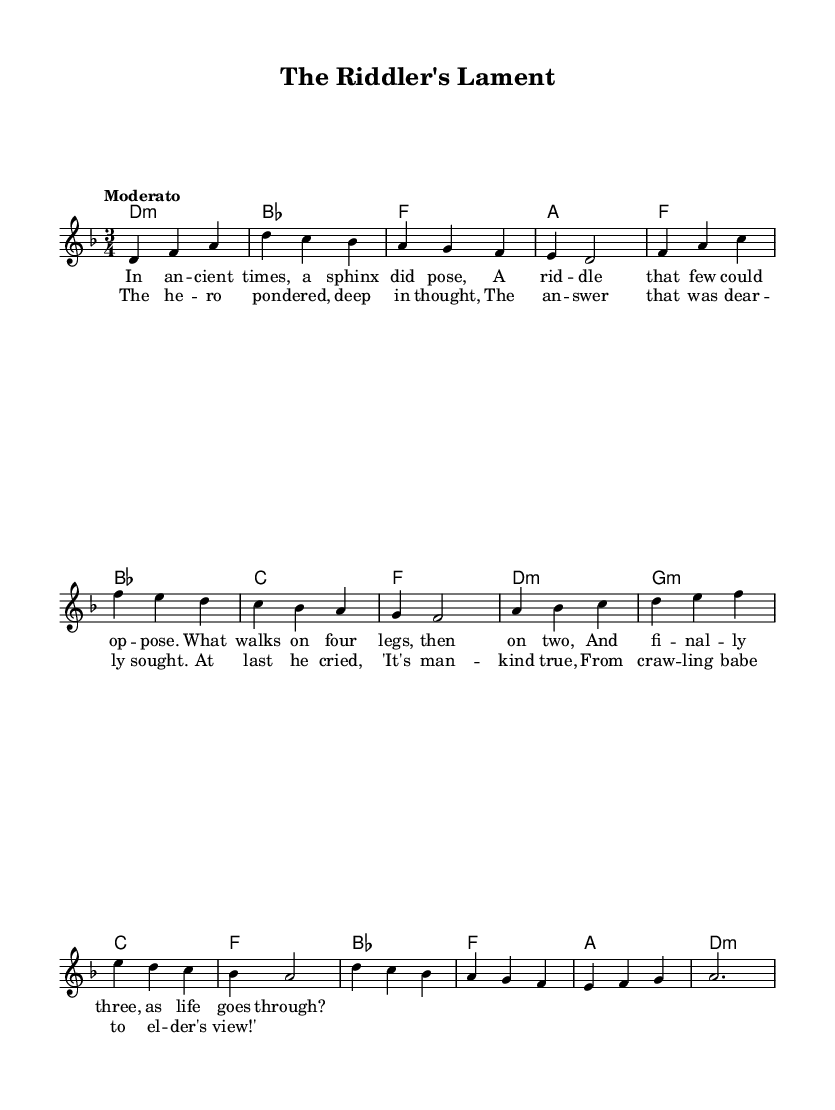What is the key signature of this music? The key signature is specified by the initial notes in the key signature area, which shows a one flat (B flat). The music is in D minor, which has one flat.
Answer: D minor What is the time signature of this music? The time signature is indicated in the beginning section of the sheet music, displaying a "3/4" time frame. This means there are three beats in each measure and the quarter note gets one beat.
Answer: 3/4 What is the tempo marking for this piece? The tempo marking appears near the beginning of the score, listed as "Moderato." This indicates a moderate speed for the piece.
Answer: Moderato How many verses are present in the lyrics? By examining the lyrical sections in the sheet music, there are two distinct parts, each labeled as a verse.
Answer: 2 What is the solution to the riddle presented in the lyrics? The solution to the riddle can be derived by closely reading the lyrics where it states, "It's mankind true," indicating the answer derived from the riddle posed in the first verse.
Answer: Mankind What is the first note of the melody? The first note of the melody is indicated at the beginning of the melody section, which shows a "D" note.
Answer: D What type of song is this? This song is characterized by its narrative and riddle, typical of folk ballads, which recount legendary brainteasers and their solutions.
Answer: Folk ballad 